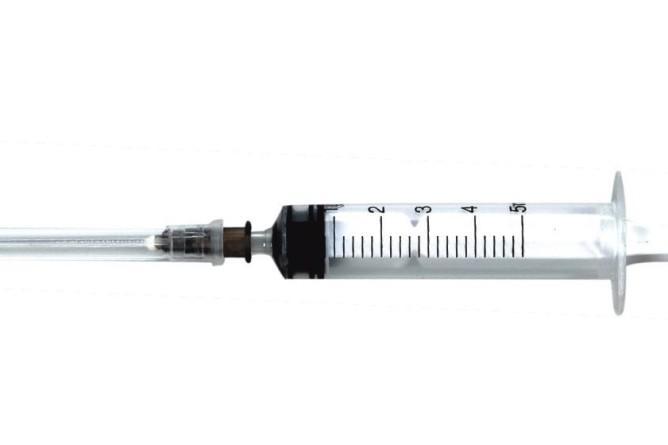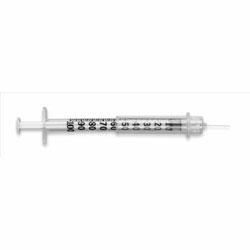The first image is the image on the left, the second image is the image on the right. Examine the images to the left and right. Is the description "Both syringes are exactly horizontal." accurate? Answer yes or no. Yes. The first image is the image on the left, the second image is the image on the right. For the images displayed, is the sentence "The left and right image contains the same number syringes facing opposite directions." factually correct? Answer yes or no. Yes. 